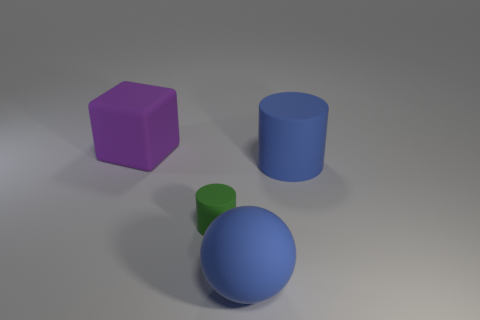Do the small green rubber thing that is in front of the blue cylinder and the large blue matte thing that is behind the green cylinder have the same shape?
Give a very brief answer. Yes. How many other objects are the same material as the large blue cylinder?
Offer a terse response. 3. There is a large thing that is behind the blue rubber object on the right side of the blue matte ball; are there any matte cylinders that are on the right side of it?
Offer a very short reply. Yes. Do the big sphere and the purple thing have the same material?
Your answer should be compact. Yes. Is there anything else that has the same shape as the big purple thing?
Provide a short and direct response. No. The small cylinder to the left of the blue rubber thing right of the sphere is made of what material?
Keep it short and to the point. Rubber. What size is the rubber cylinder left of the big sphere?
Your response must be concise. Small. The rubber object that is both behind the blue ball and in front of the large rubber cylinder is what color?
Ensure brevity in your answer.  Green. Do the purple rubber block left of the blue cylinder and the blue rubber cylinder have the same size?
Your answer should be compact. Yes. Is there a blue rubber thing that is right of the large thing in front of the green cylinder?
Keep it short and to the point. Yes. 